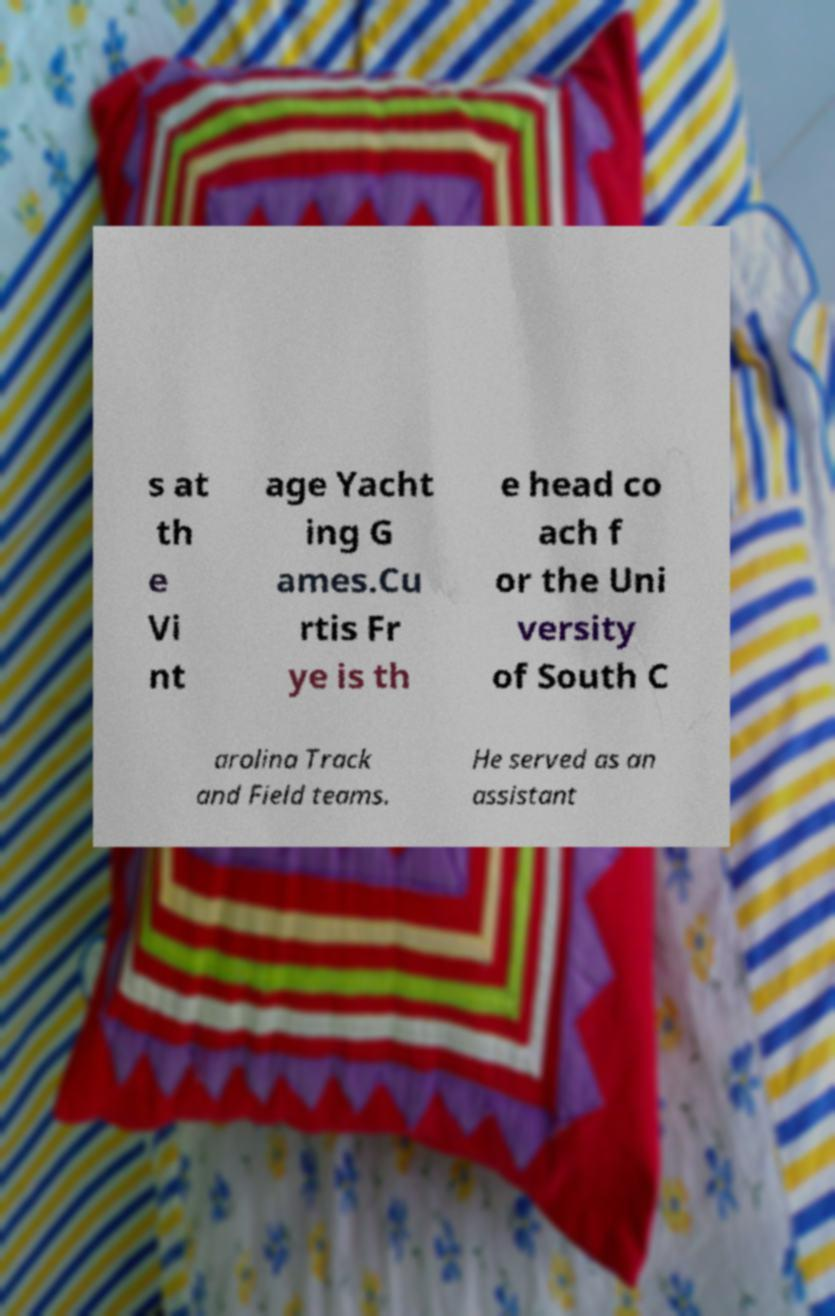There's text embedded in this image that I need extracted. Can you transcribe it verbatim? s at th e Vi nt age Yacht ing G ames.Cu rtis Fr ye is th e head co ach f or the Uni versity of South C arolina Track and Field teams. He served as an assistant 